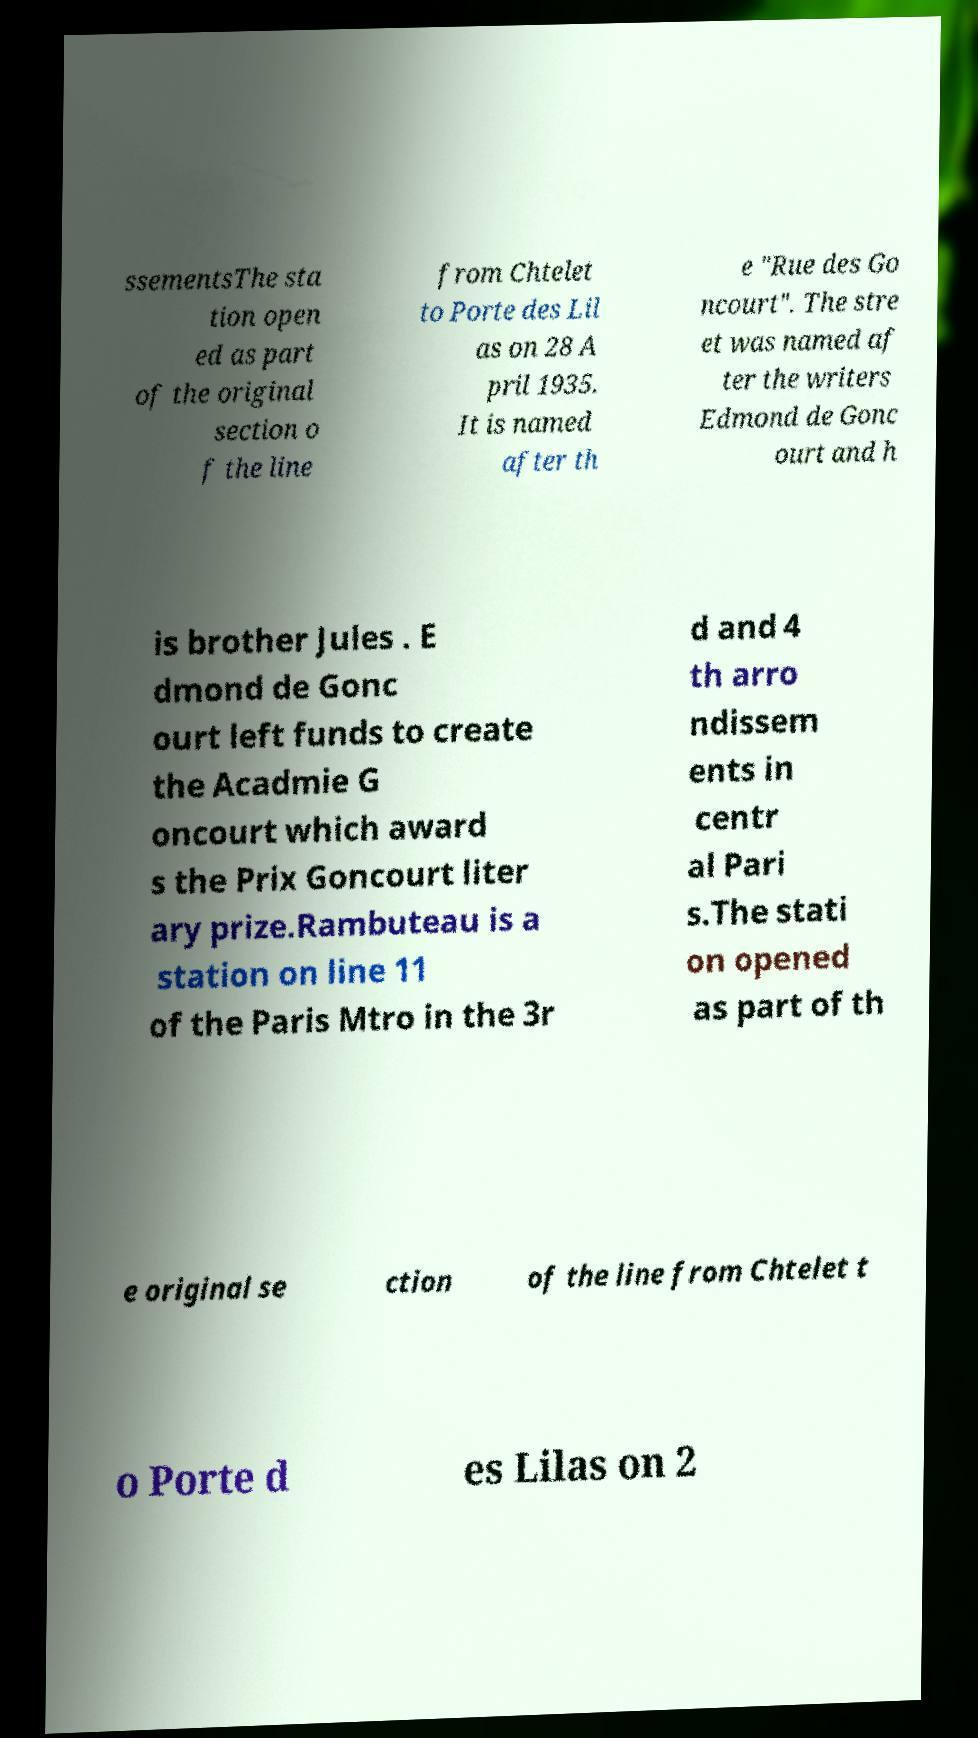I need the written content from this picture converted into text. Can you do that? ssementsThe sta tion open ed as part of the original section o f the line from Chtelet to Porte des Lil as on 28 A pril 1935. It is named after th e "Rue des Go ncourt". The stre et was named af ter the writers Edmond de Gonc ourt and h is brother Jules . E dmond de Gonc ourt left funds to create the Acadmie G oncourt which award s the Prix Goncourt liter ary prize.Rambuteau is a station on line 11 of the Paris Mtro in the 3r d and 4 th arro ndissem ents in centr al Pari s.The stati on opened as part of th e original se ction of the line from Chtelet t o Porte d es Lilas on 2 